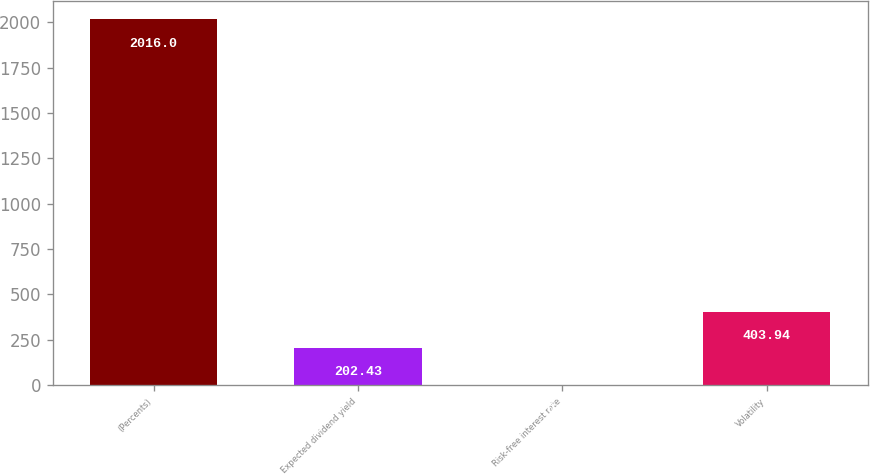Convert chart to OTSL. <chart><loc_0><loc_0><loc_500><loc_500><bar_chart><fcel>(Percents)<fcel>Expected dividend yield<fcel>Risk-free interest rate<fcel>Volatility<nl><fcel>2016<fcel>202.43<fcel>0.92<fcel>403.94<nl></chart> 